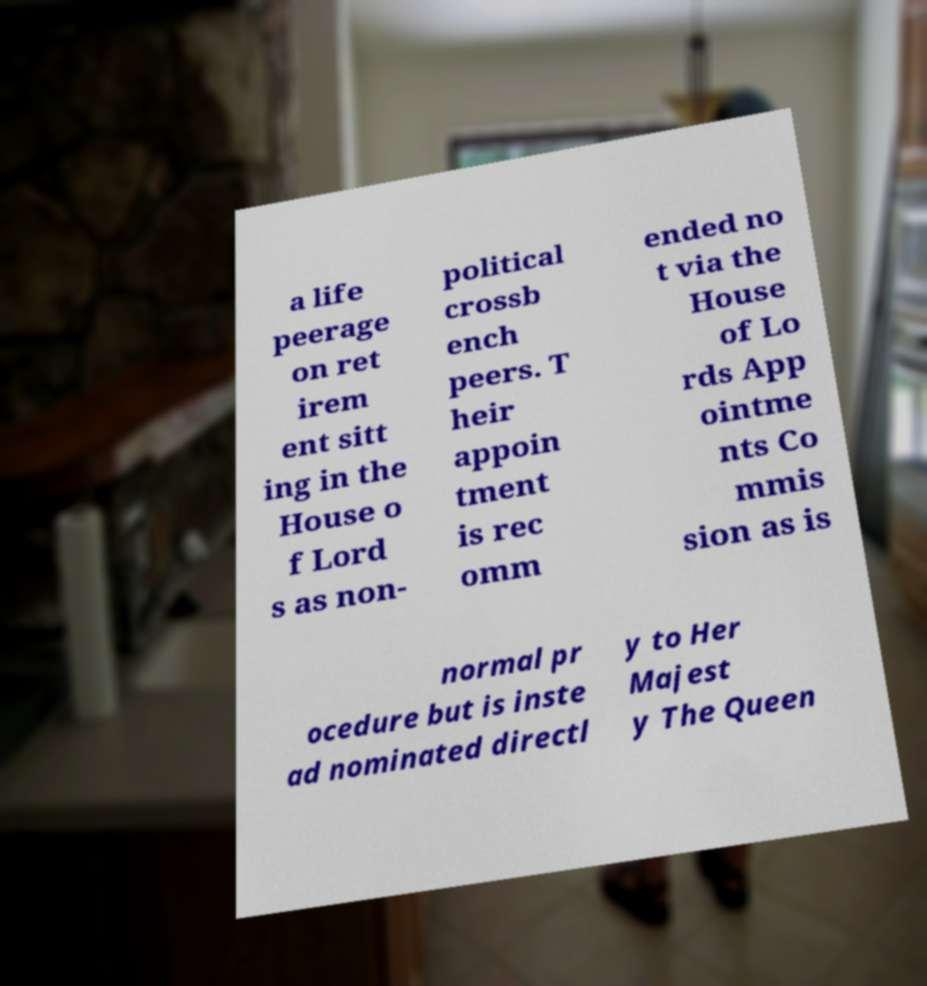Please read and relay the text visible in this image. What does it say? a life peerage on ret irem ent sitt ing in the House o f Lord s as non- political crossb ench peers. T heir appoin tment is rec omm ended no t via the House of Lo rds App ointme nts Co mmis sion as is normal pr ocedure but is inste ad nominated directl y to Her Majest y The Queen 